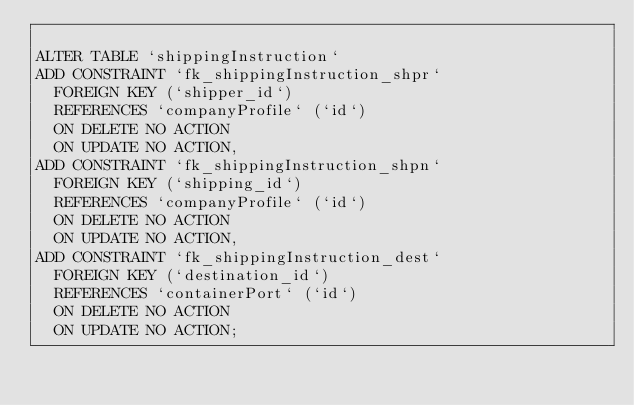Convert code to text. <code><loc_0><loc_0><loc_500><loc_500><_SQL_>
ALTER TABLE `shippingInstruction`
ADD CONSTRAINT `fk_shippingInstruction_shpr`
  FOREIGN KEY (`shipper_id`)
  REFERENCES `companyProfile` (`id`)
  ON DELETE NO ACTION
  ON UPDATE NO ACTION,
ADD CONSTRAINT `fk_shippingInstruction_shpn`
  FOREIGN KEY (`shipping_id`)
  REFERENCES `companyProfile` (`id`)
  ON DELETE NO ACTION
  ON UPDATE NO ACTION,
ADD CONSTRAINT `fk_shippingInstruction_dest`
  FOREIGN KEY (`destination_id`)
  REFERENCES `containerPort` (`id`)
  ON DELETE NO ACTION
  ON UPDATE NO ACTION;
</code> 